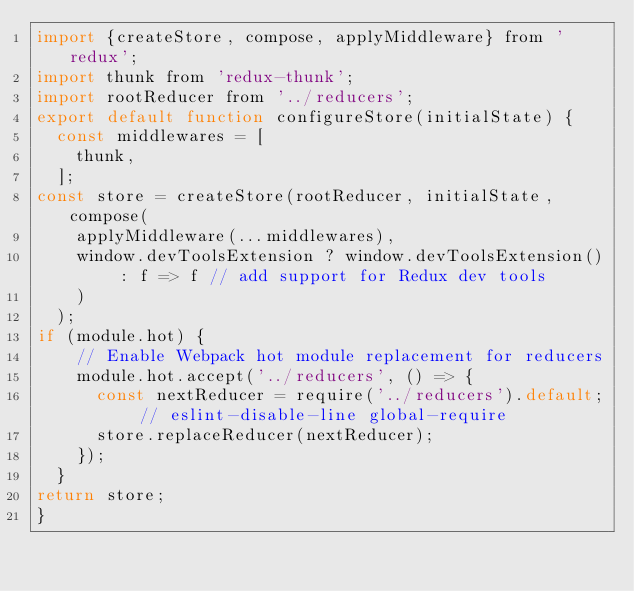<code> <loc_0><loc_0><loc_500><loc_500><_JavaScript_>import {createStore, compose, applyMiddleware} from 'redux';
import thunk from 'redux-thunk';
import rootReducer from '../reducers';
export default function configureStore(initialState) {
  const middlewares = [
    thunk,
  ];
const store = createStore(rootReducer, initialState, compose(
    applyMiddleware(...middlewares),
    window.devToolsExtension ? window.devToolsExtension() : f => f // add support for Redux dev tools
    )
  );
if (module.hot) {
    // Enable Webpack hot module replacement for reducers
    module.hot.accept('../reducers', () => {
      const nextReducer = require('../reducers').default; // eslint-disable-line global-require
      store.replaceReducer(nextReducer);
    });
  }
return store;
}</code> 